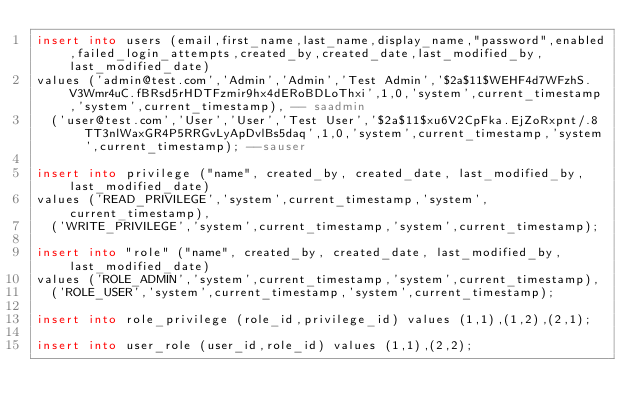<code> <loc_0><loc_0><loc_500><loc_500><_SQL_>insert into users (email,first_name,last_name,display_name,"password",enabled,failed_login_attempts,created_by,created_date,last_modified_by,last_modified_date)
values ('admin@test.com','Admin','Admin','Test Admin','$2a$11$WEHF4d7WFzhS.V3Wmr4uC.fBRsd5rHDTFzmir9hx4dERoBDLoThxi',1,0,'system',current_timestamp,'system',current_timestamp), -- saadmin
	('user@test.com','User','User','Test User','$2a$11$xu6V2CpFka.EjZoRxpnt/.8TT3nlWaxGR4P5RRGvLyApDvlBs5daq',1,0,'system',current_timestamp,'system',current_timestamp); --sauser

insert into privilege ("name", created_by, created_date, last_modified_by, last_modified_date)
values ('READ_PRIVILEGE','system',current_timestamp,'system',current_timestamp),
	('WRITE_PRIVILEGE','system',current_timestamp,'system',current_timestamp);

insert into "role" ("name", created_by, created_date, last_modified_by, last_modified_date)
values ('ROLE_ADMIN','system',current_timestamp,'system',current_timestamp),
	('ROLE_USER','system',current_timestamp,'system',current_timestamp);
	
insert into role_privilege (role_id,privilege_id) values (1,1),(1,2),(2,1);

insert into user_role (user_id,role_id) values (1,1),(2,2);
</code> 